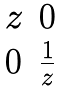<formula> <loc_0><loc_0><loc_500><loc_500>\begin{matrix} z & 0 \\ 0 & \frac { 1 } { z } \end{matrix}</formula> 